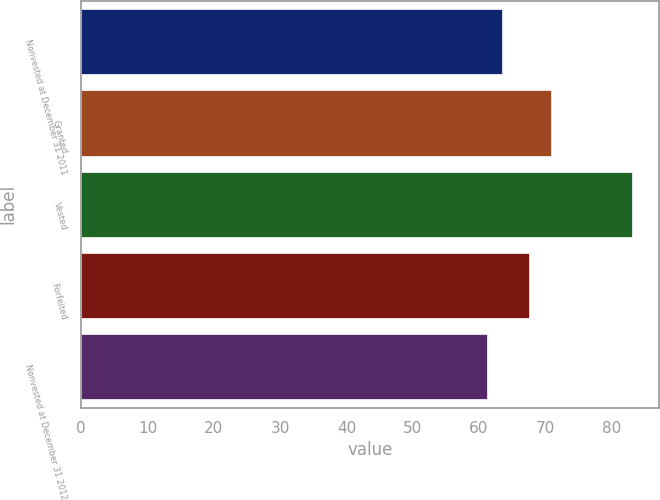Convert chart. <chart><loc_0><loc_0><loc_500><loc_500><bar_chart><fcel>Nonvested at December 31 2011<fcel>Granted<fcel>Vested<fcel>Forfeited<fcel>Nonvested at December 31 2012<nl><fcel>63.41<fcel>70.86<fcel>83.03<fcel>67.53<fcel>61.23<nl></chart> 